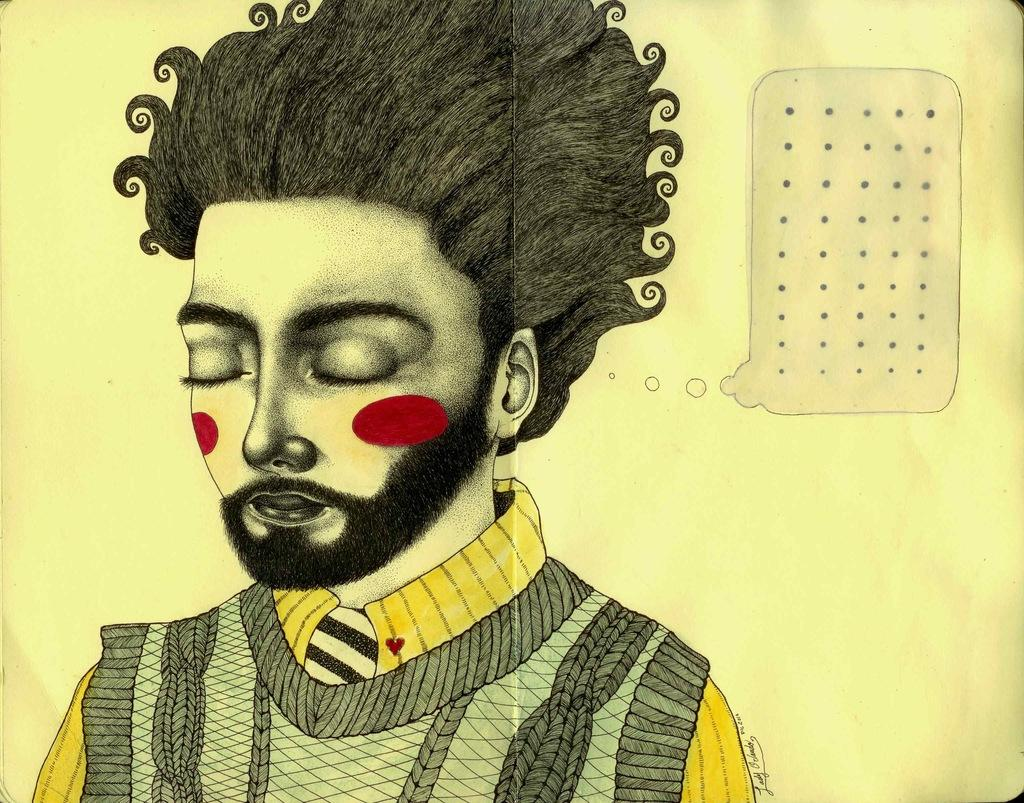What is the main subject in the foreground of the image? There is a person in the foreground of the image. What can be seen in the background of the image? There is a wall in the background of the image. Can you describe the object visible on the wall? Unfortunately, the facts provided do not give enough information to describe the object on the wall. How many balloons are tied to the shirt in the image? There is no shirt or balloons present in the image. 